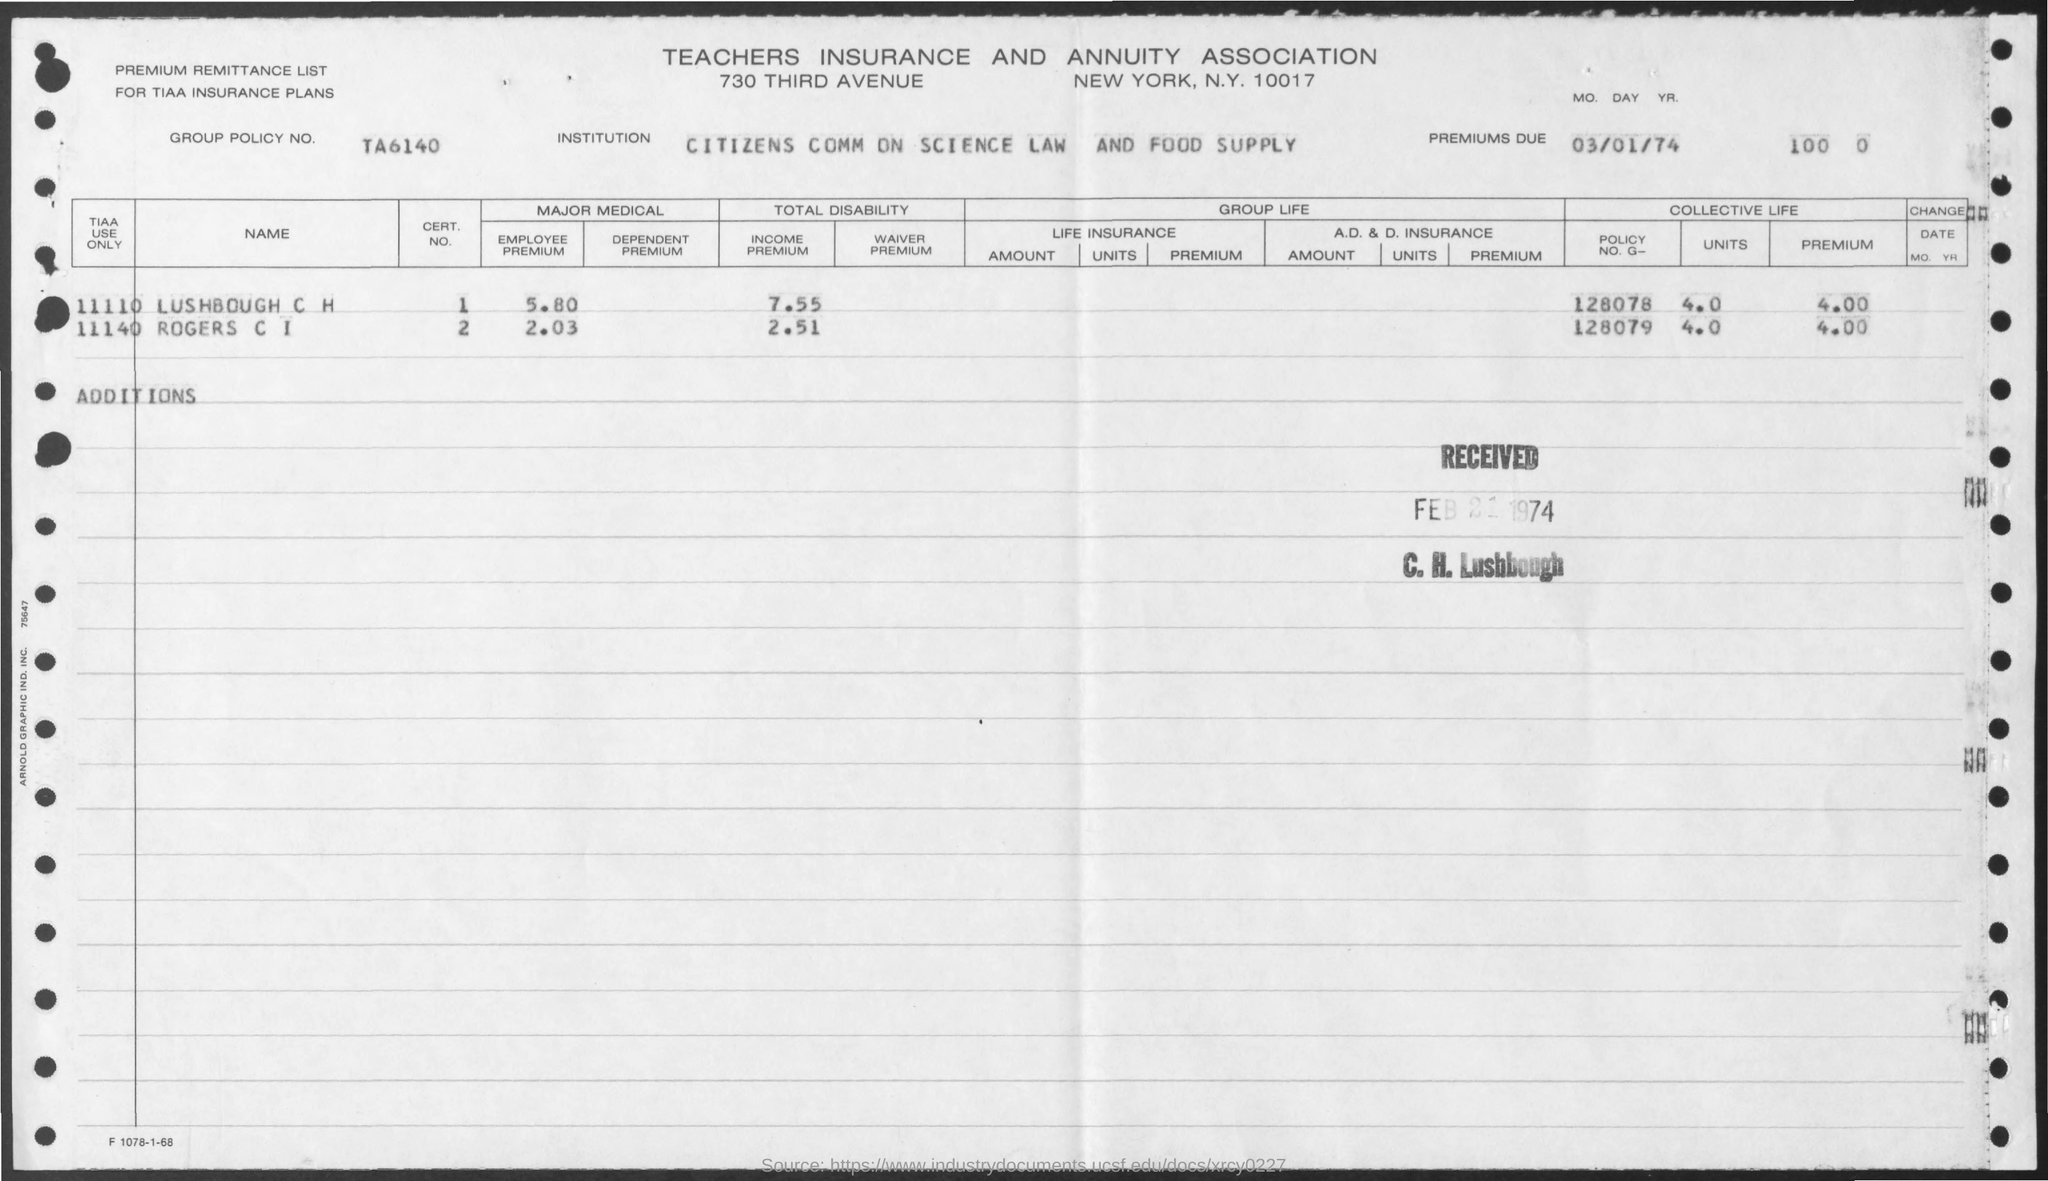Whats the GROUP POLICY NO.?
Offer a very short reply. TA6140. Whats the EMPLOYEE PREMIUM of ROGERS CI?
Your response must be concise. 2.03. Whose POLICY NO G_ 128078 this?
Provide a short and direct response. LUSHBOUGH C H. Whats the INCOME PREMIUM of LUSHBOUGH C  H?
Keep it short and to the point. 7.55. When was the premium due date?
Provide a short and direct response. 03/01/74. When was this form received?
Your answer should be compact. Feb 21, 1974. 